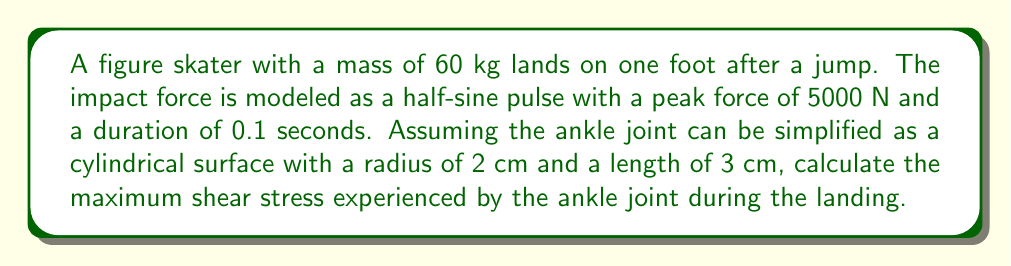Teach me how to tackle this problem. To solve this problem, we'll follow these steps:

1) First, we need to determine the maximum force applied to the ankle joint. The impact force is modeled as a half-sine pulse, so the maximum force is given:

   $F_{max} = 5000 \text{ N}$

2) The area of the simplified cylindrical ankle joint surface is:

   $A = 2\pi r l$

   where $r$ is the radius and $l$ is the length of the cylinder.

   $A = 2\pi (0.02 \text{ m})(0.03 \text{ m}) = 3.77 \times 10^{-3} \text{ m}^2$

3) The average normal stress on the joint is:

   $\sigma = \frac{F_{max}}{A} = \frac{5000 \text{ N}}{3.77 \times 10^{-3} \text{ m}^2} = 1.33 \times 10^6 \text{ Pa}$

4) In most materials, the maximum shear stress is related to the normal stress by:

   $\tau_{max} = \frac{\sigma}{2}$

5) Therefore, the maximum shear stress is:

   $\tau_{max} = \frac{1.33 \times 10^6 \text{ Pa}}{2} = 6.65 \times 10^5 \text{ Pa}$

This result represents the maximum shear stress experienced by the simplified ankle joint model during the landing impact.
Answer: $\tau_{max} = 6.65 \times 10^5 \text{ Pa}$ 